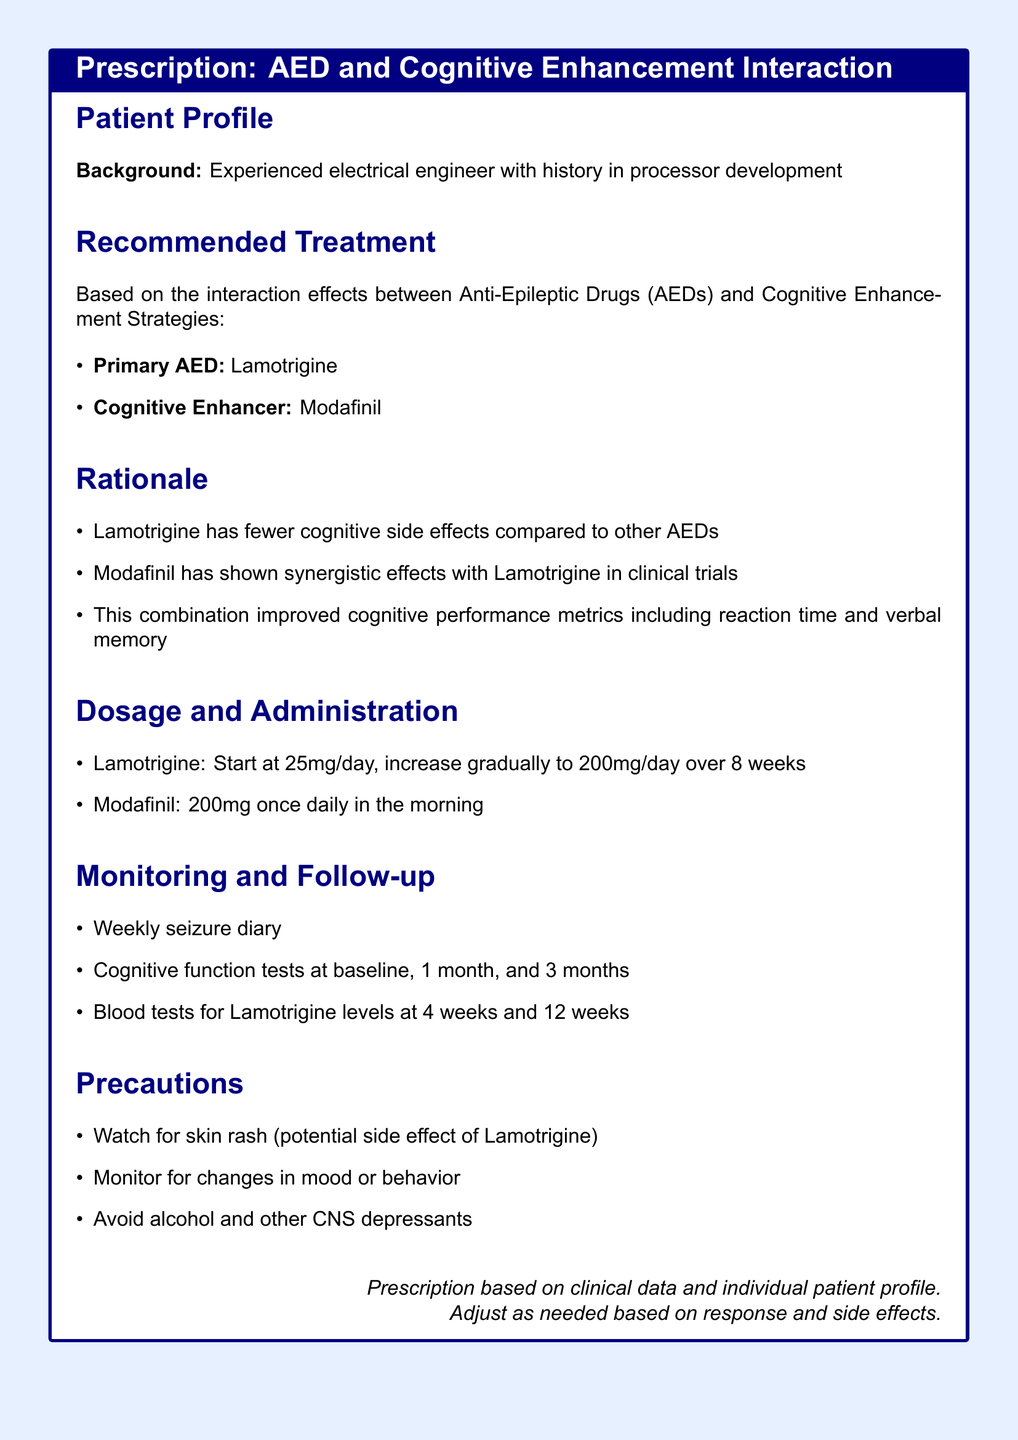What is the primary AED recommended? The document explicitly states that Lamotrigine is the primary AED recommended for the patient.
Answer: Lamotrigine What is the dosage for Lamotrigine at the start of treatment? The document indicates that the starting dosage of Lamotrigine is 25mg/day.
Answer: 25mg/day How often should cognitive function tests be conducted? According to the document, cognitive function tests should be done at baseline, 1 month, and 3 months.
Answer: 3 times What is the recommended dosage of Modafinil? The document specifies that the recommended dosage of Modafinil is 200mg once daily in the morning.
Answer: 200mg What should be monitored for as a precaution? The document mentions the need to watch for skin rash as a potential side effect of Lamotrigine.
Answer: Skin rash What is one positive effect noted in clinical trials for the combination of Lamotrigine and Modafinil? The document states that this combination improved cognitive performance metrics including reaction time.
Answer: Reaction time How long should Lamotrigine be increased gradually over? The document indicates that Lamotrigine should be gradually increased over 8 weeks.
Answer: 8 weeks What lifestyle change is recommended to avoid side effects? The document advises avoiding alcohol and other CNS depressants as a precaution.
Answer: Avoid alcohol What is a key requirement in follow-up monitoring? Weekly seizure diary is explicitly mentioned as a requirement in follow-up monitoring.
Answer: Weekly seizure diary 